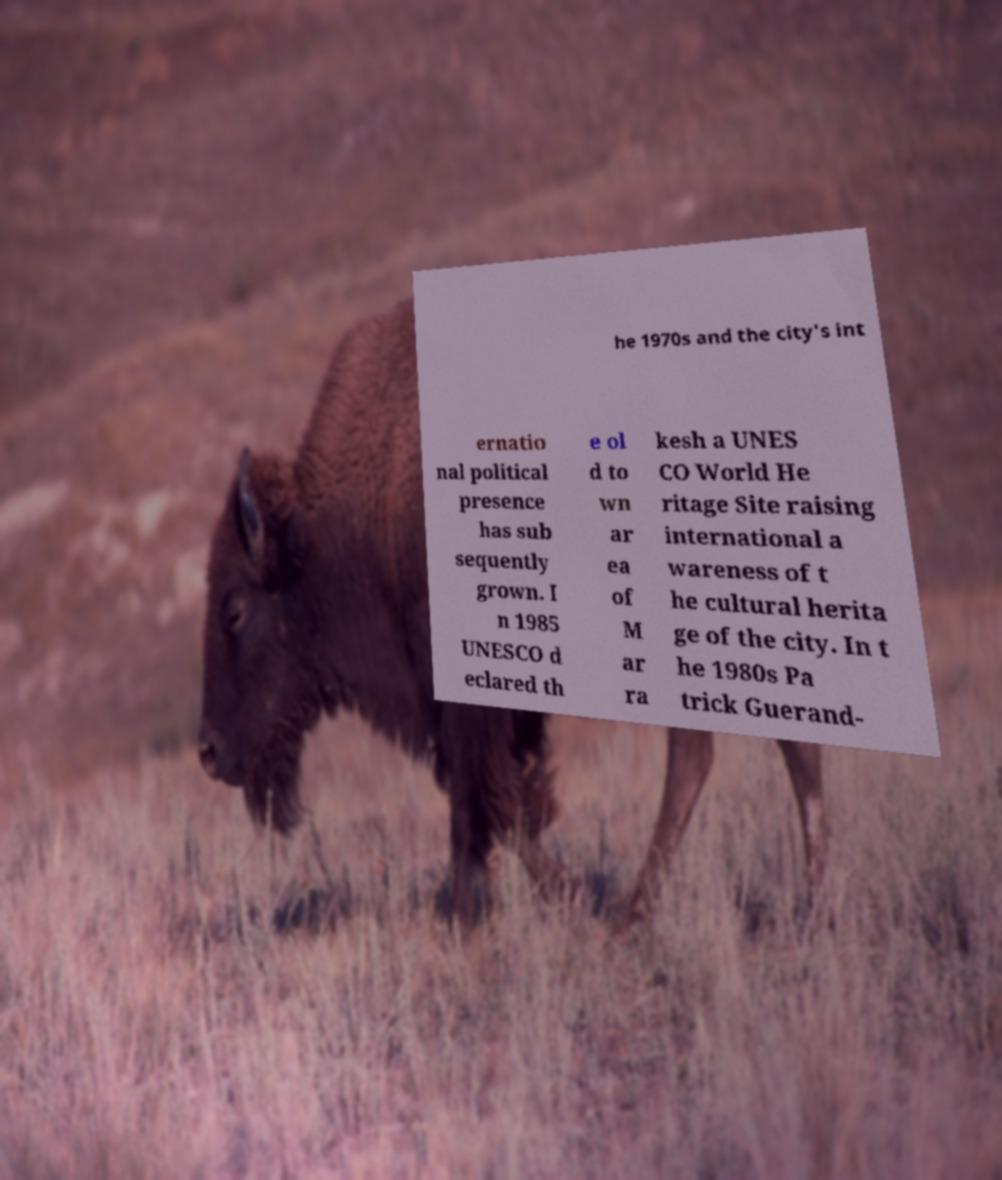For documentation purposes, I need the text within this image transcribed. Could you provide that? he 1970s and the city's int ernatio nal political presence has sub sequently grown. I n 1985 UNESCO d eclared th e ol d to wn ar ea of M ar ra kesh a UNES CO World He ritage Site raising international a wareness of t he cultural herita ge of the city. In t he 1980s Pa trick Guerand- 